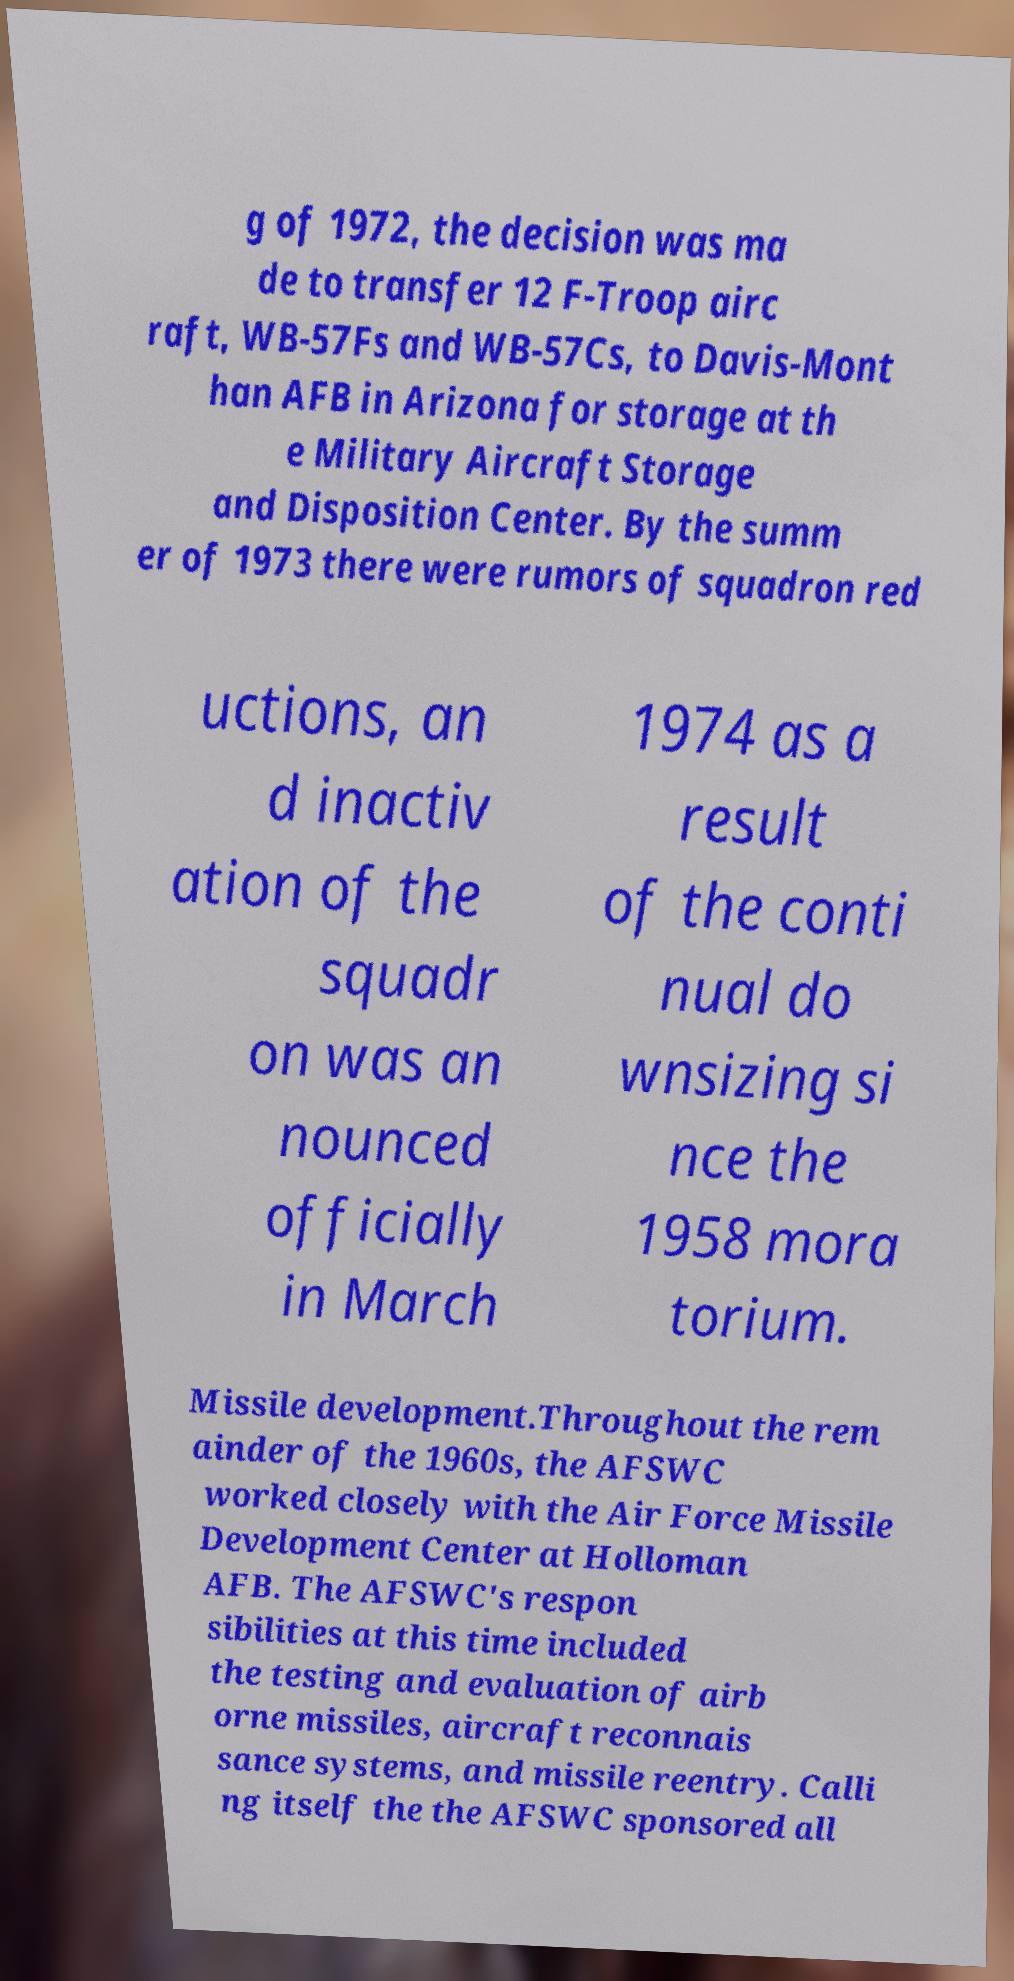What messages or text are displayed in this image? I need them in a readable, typed format. g of 1972, the decision was ma de to transfer 12 F-Troop airc raft, WB-57Fs and WB-57Cs, to Davis-Mont han AFB in Arizona for storage at th e Military Aircraft Storage and Disposition Center. By the summ er of 1973 there were rumors of squadron red uctions, an d inactiv ation of the squadr on was an nounced officially in March 1974 as a result of the conti nual do wnsizing si nce the 1958 mora torium. Missile development.Throughout the rem ainder of the 1960s, the AFSWC worked closely with the Air Force Missile Development Center at Holloman AFB. The AFSWC's respon sibilities at this time included the testing and evaluation of airb orne missiles, aircraft reconnais sance systems, and missile reentry. Calli ng itself the the AFSWC sponsored all 